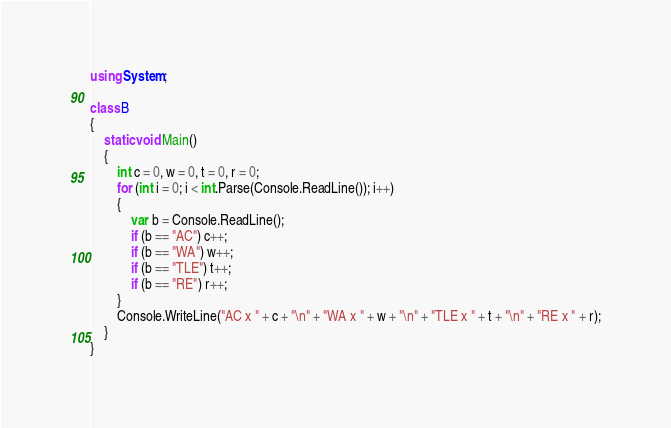<code> <loc_0><loc_0><loc_500><loc_500><_C#_>using System;

class B
{
	static void Main()
	{
		int c = 0, w = 0, t = 0, r = 0;
		for (int i = 0; i < int.Parse(Console.ReadLine()); i++)
		{
			var b = Console.ReadLine();
			if (b == "AC") c++;
			if (b == "WA") w++;
			if (b == "TLE") t++;
			if (b == "RE") r++;
		}
		Console.WriteLine("AC x " + c + "\n" + "WA x " + w + "\n" + "TLE x " + t + "\n" + "RE x " + r);
	}
}</code> 